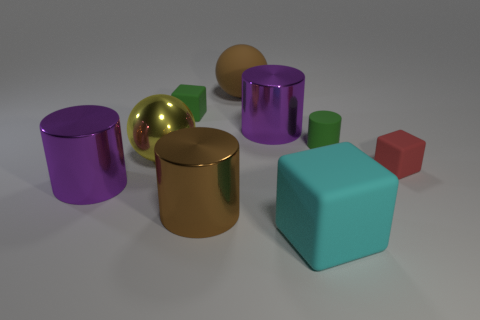There is a brown cylinder that is the same size as the brown sphere; what is it made of?
Provide a short and direct response. Metal. Are there any green objects that have the same material as the green cube?
Your answer should be compact. Yes. Is the shape of the cyan thing the same as the green object that is to the right of the cyan cube?
Provide a short and direct response. No. How many objects are to the right of the large cyan rubber block and behind the yellow metallic thing?
Offer a terse response. 1. Are the large cube and the small green block behind the big yellow metallic thing made of the same material?
Provide a short and direct response. Yes. Are there the same number of yellow spheres behind the big rubber sphere and tiny blue blocks?
Keep it short and to the point. Yes. What color is the rubber cube that is left of the big cyan cube?
Your answer should be compact. Green. What number of other objects are there of the same color as the large matte sphere?
Your answer should be compact. 1. There is a green rubber object on the right side of the brown sphere; is it the same size as the large block?
Ensure brevity in your answer.  No. There is a big purple cylinder that is on the right side of the large yellow metal sphere; what material is it?
Provide a short and direct response. Metal. 